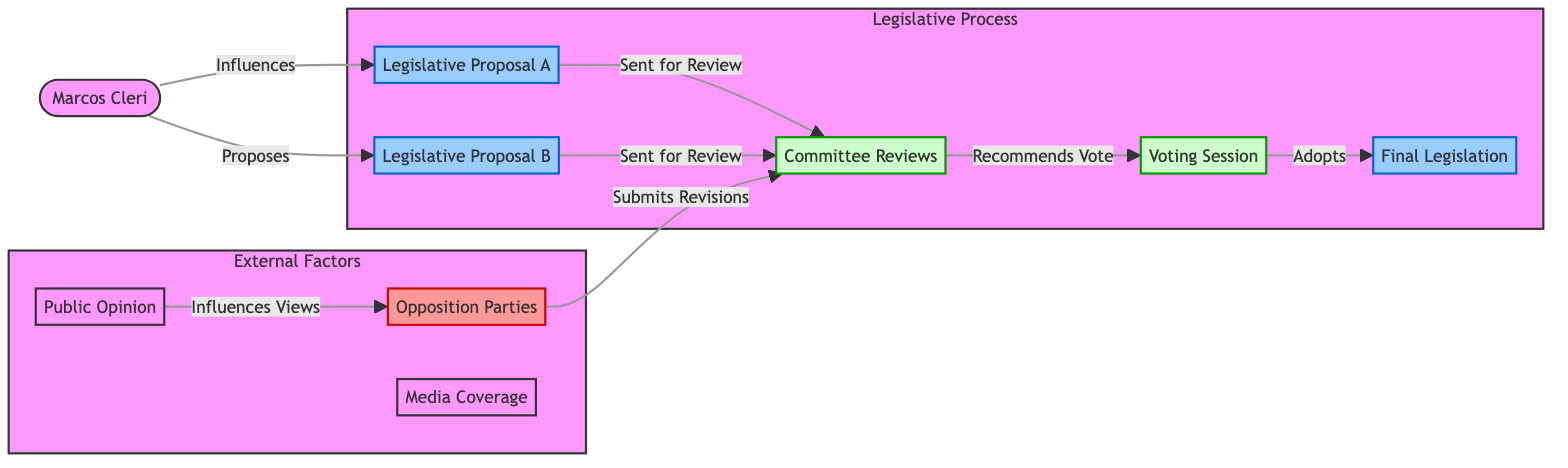What's the total number of nodes in the diagram? The diagram lists nine distinct nodes: Marcos Cleri, Legislative Proposal A, Legislative Proposal B, Public Opinion, Opposition Parties, Media Coverage, Committee Reviews, Voting Session, and Final Legislation. Counting these gives a total of nine nodes.
Answer: 9 How many edges originate from Marcos Cleri? There are two directed edges that originate from Marcos Cleri. One leads to Legislative Proposal A (labeled "Influences") and the other leads to Legislative Proposal B (labeled "Proposes"). Counting these shows that there are two edges originating from Marcos Cleri.
Answer: 2 Which node receives the recommendation to vote? The Voting Session node receives the recommendation to vote as indicated by the edge leading from the Committee Reviews node to the Voting Session node with the label "Recommends Vote."
Answer: Voting Session How does Public Opinion affect Opposition Parties? Public Opinion influences the views of Opposition Parties, represented by the directed edge from Public Opinion to Opposition Parties labeled "Influences Views." Thus, Public Opinion directly impacts the perspectives of the Opposition Parties.
Answer: Influences Views What is the final outcome of the voting session? The final outcome of the voting session is the Final Legislation, as shown by the edge signaling that the Voting Session adopts the final legislation. Thus, the final legislation is the result of the voting session.
Answer: Final Legislation What action do Opposition Parties take in response to committee reviews? Opposition Parties submit revisions in response to committee reviews, as indicated by the directed edge from Opposition Parties to Committee Reviews with the label "Submits Revisions." This signifies that they actively engage with the legislative process.
Answer: Submits Revisions How many legislative proposals are sent for review? Two legislative proposals are sent for review, namely Legislative Proposal A and Legislative Proposal B, both of which have edges directed towards Committee Reviews labeled "Sent for Review." Therefore, the total count is two legislative proposals sent for review.
Answer: 2 Which node is the starting point of the legislative process? The starting point of the legislative process is Legislative Proposal A and Legislative Proposal B, as these proposals are influenced and proposed by Marcos Cleri and subsequently sent to committee reviews. Thus, these are the initial nodes in this flow.
Answer: Legislative Proposal A and Legislative Proposal B 